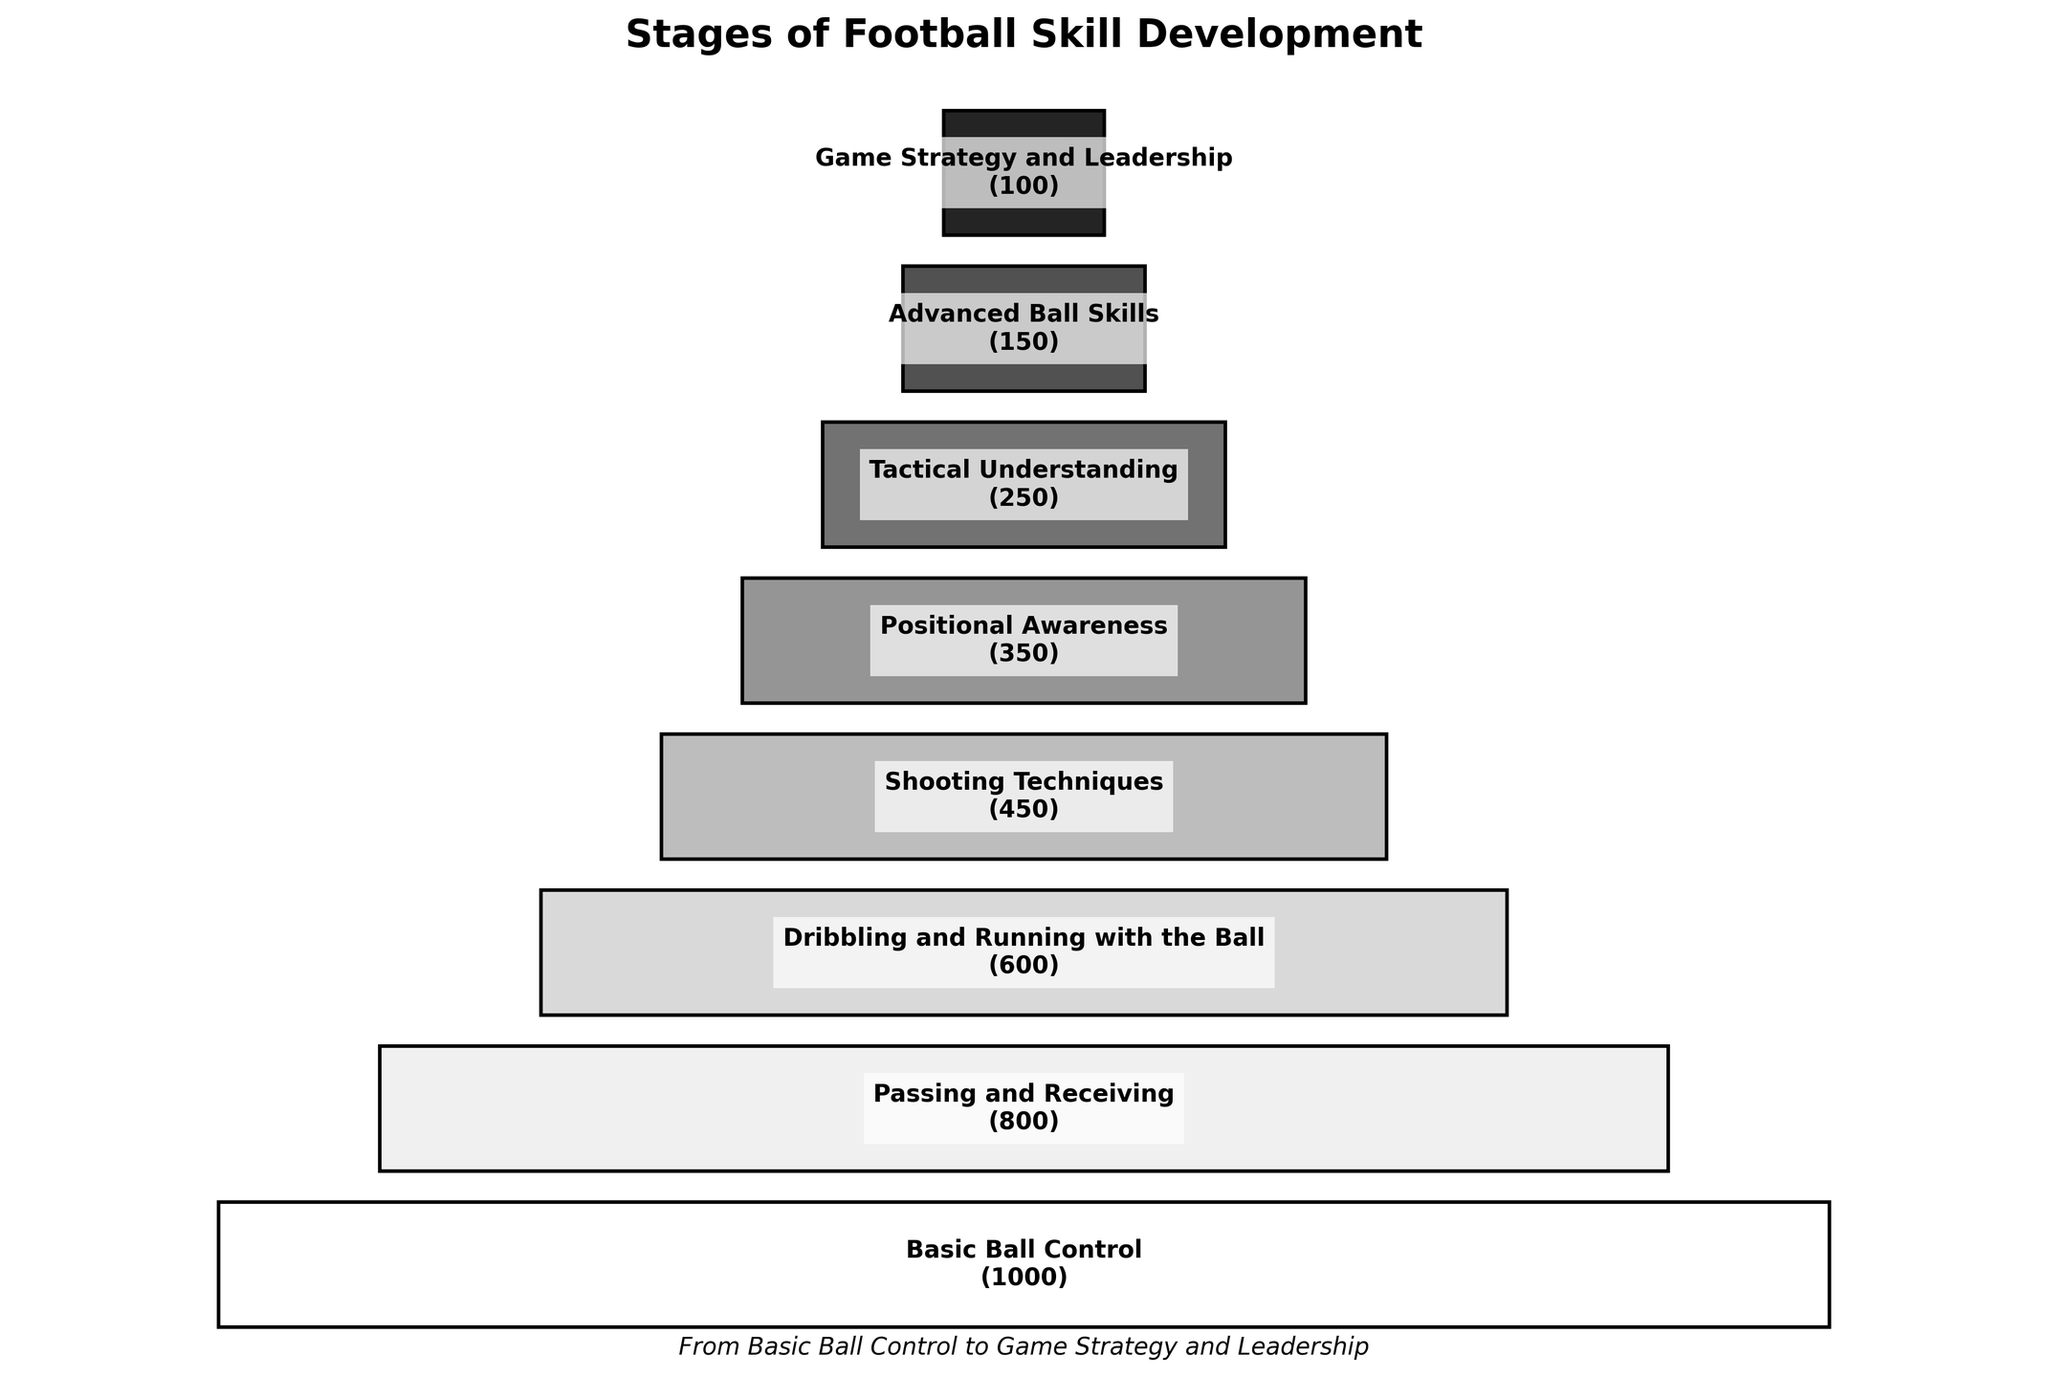what is the title of the chart? The title of the chart is usually displayed at the top of the plot in a larger or bolder font compared to the other text. In this chart, the title is clearly stated.
Answer: Stages of Football Skill Development what is the final stage of football skill development shown on the chart? The final stage is typically the bottom-most segment in a funnel chart, representing the last step in the progression.
Answer: Game Strategy and Leadership How many players progressed to the stage 'Shooting Techniques'? The number of players progressing to each stage is labeled in parentheses next to the stage name. For 'Shooting Techniques', it shows 450.
Answer: 450 Which stage saw the largest drop in the number of progressing players compared to the previous stage? By looking at the difference in the number of players between consecutive stages, the largest drop can be identified. The drop from 'Shooting Techniques' (450) to 'Positional Awareness' (350) is 100, which is the largest.
Answer: Shooting Techniques to Positional Awareness what is the average number of players progressing between all the stages? To find the average, sum the number of players progressing at each stage and divide by the total number of stages. (1000 + 800 + 600 + 450 + 350 + 250 + 150 + 100) / 8 = 3700 / 8 = 462.5
Answer: 462.5 Which stage has the second highest number of players progressing? The stages can be ordered by the number of progressing players. 'Basic Ball Control' has the highest (1000), followed by 'Passing and Receiving' with 800 players progressing.
Answer: Passing and Receiving What percentage of players moved from 'Basic Ball Control' to 'Advanced Ball Skills'? The percentage can be calculated by dividing the number of players in 'Advanced Ball Skills' by those in 'Basic Ball Control' and multiplying by 100. (150 / 1000) * 100 = 15%
Answer: 15% How many more players progressed through 'Dribbling and Running with the Ball' than 'Positional Awareness'? The difference between these two stages is calculated by subtracting the number of players in 'Positional Awareness' from those in 'Dribbling and Running with the Ball'. 600 - 350 = 250
Answer: 250 What is the sum of players in the first three stages? Add the number of players progressing in 'Basic Ball Control', 'Passing and Receiving', and 'Dribbling and Running with the Ball'. 1000 + 800 + 600 = 2400
Answer: 2400 Which stage has the smallest number of progressing players? The smallest segment in the funnel would represent the stage with the least players. 'Game Strategy and Leadership' with 100 players is the smallest.
Answer: Game Strategy and Leadership 